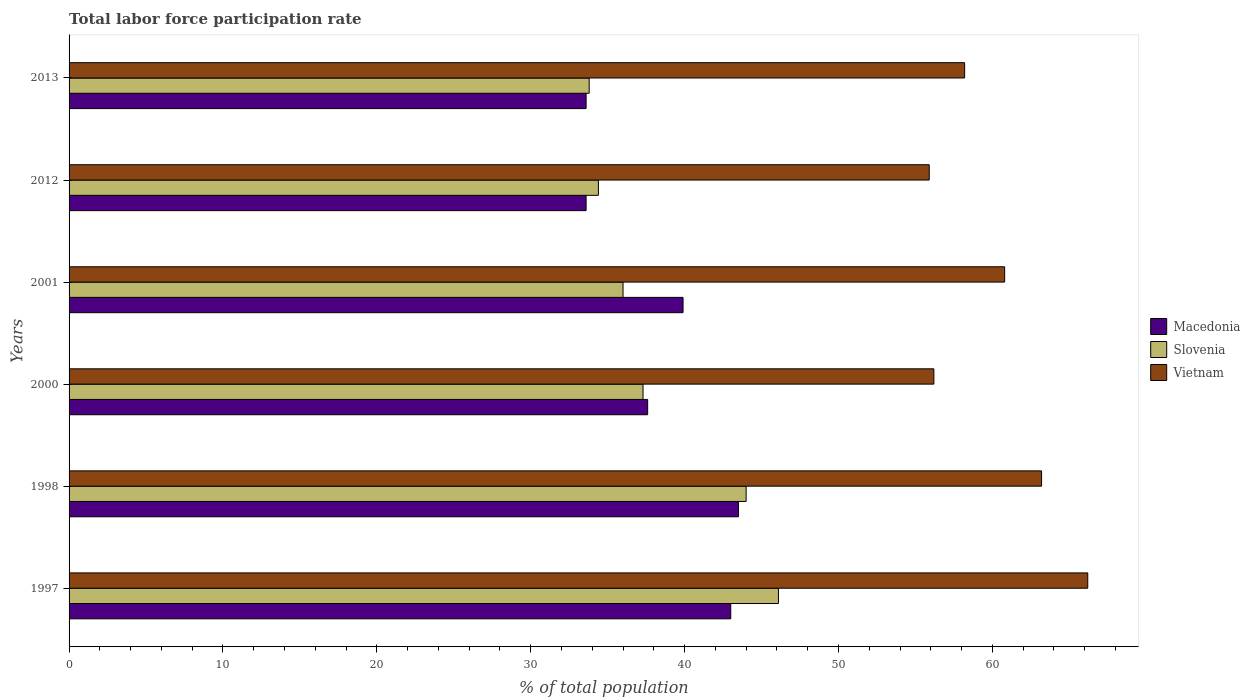Are the number of bars per tick equal to the number of legend labels?
Provide a succinct answer. Yes. How many bars are there on the 1st tick from the bottom?
Provide a succinct answer. 3. Across all years, what is the maximum total labor force participation rate in Macedonia?
Offer a very short reply. 43.5. Across all years, what is the minimum total labor force participation rate in Vietnam?
Ensure brevity in your answer.  55.9. In which year was the total labor force participation rate in Macedonia maximum?
Make the answer very short. 1998. In which year was the total labor force participation rate in Slovenia minimum?
Make the answer very short. 2013. What is the total total labor force participation rate in Slovenia in the graph?
Offer a terse response. 231.6. What is the difference between the total labor force participation rate in Slovenia in 1998 and the total labor force participation rate in Macedonia in 2012?
Your answer should be compact. 10.4. What is the average total labor force participation rate in Vietnam per year?
Give a very brief answer. 60.08. In the year 1998, what is the difference between the total labor force participation rate in Macedonia and total labor force participation rate in Slovenia?
Your answer should be compact. -0.5. In how many years, is the total labor force participation rate in Macedonia greater than 32 %?
Your response must be concise. 6. What is the ratio of the total labor force participation rate in Vietnam in 1998 to that in 2013?
Make the answer very short. 1.09. Is the total labor force participation rate in Macedonia in 2000 less than that in 2001?
Offer a terse response. Yes. Is the difference between the total labor force participation rate in Macedonia in 2000 and 2012 greater than the difference between the total labor force participation rate in Slovenia in 2000 and 2012?
Your answer should be very brief. Yes. What is the difference between the highest and the lowest total labor force participation rate in Macedonia?
Provide a short and direct response. 9.9. In how many years, is the total labor force participation rate in Slovenia greater than the average total labor force participation rate in Slovenia taken over all years?
Keep it short and to the point. 2. What does the 2nd bar from the top in 1997 represents?
Make the answer very short. Slovenia. What does the 3rd bar from the bottom in 1997 represents?
Provide a succinct answer. Vietnam. Is it the case that in every year, the sum of the total labor force participation rate in Vietnam and total labor force participation rate in Slovenia is greater than the total labor force participation rate in Macedonia?
Your answer should be very brief. Yes. How many bars are there?
Your answer should be very brief. 18. Are all the bars in the graph horizontal?
Provide a short and direct response. Yes. What is the difference between two consecutive major ticks on the X-axis?
Keep it short and to the point. 10. Are the values on the major ticks of X-axis written in scientific E-notation?
Make the answer very short. No. Does the graph contain any zero values?
Keep it short and to the point. No. Where does the legend appear in the graph?
Give a very brief answer. Center right. How many legend labels are there?
Ensure brevity in your answer.  3. How are the legend labels stacked?
Offer a terse response. Vertical. What is the title of the graph?
Make the answer very short. Total labor force participation rate. What is the label or title of the X-axis?
Provide a succinct answer. % of total population. What is the label or title of the Y-axis?
Your answer should be very brief. Years. What is the % of total population of Slovenia in 1997?
Your response must be concise. 46.1. What is the % of total population of Vietnam in 1997?
Provide a succinct answer. 66.2. What is the % of total population in Macedonia in 1998?
Provide a short and direct response. 43.5. What is the % of total population in Slovenia in 1998?
Ensure brevity in your answer.  44. What is the % of total population of Vietnam in 1998?
Provide a succinct answer. 63.2. What is the % of total population in Macedonia in 2000?
Make the answer very short. 37.6. What is the % of total population of Slovenia in 2000?
Give a very brief answer. 37.3. What is the % of total population in Vietnam in 2000?
Offer a very short reply. 56.2. What is the % of total population in Macedonia in 2001?
Your response must be concise. 39.9. What is the % of total population of Vietnam in 2001?
Keep it short and to the point. 60.8. What is the % of total population of Macedonia in 2012?
Offer a very short reply. 33.6. What is the % of total population of Slovenia in 2012?
Provide a short and direct response. 34.4. What is the % of total population in Vietnam in 2012?
Provide a short and direct response. 55.9. What is the % of total population in Macedonia in 2013?
Ensure brevity in your answer.  33.6. What is the % of total population in Slovenia in 2013?
Make the answer very short. 33.8. What is the % of total population of Vietnam in 2013?
Provide a succinct answer. 58.2. Across all years, what is the maximum % of total population of Macedonia?
Ensure brevity in your answer.  43.5. Across all years, what is the maximum % of total population in Slovenia?
Offer a terse response. 46.1. Across all years, what is the maximum % of total population of Vietnam?
Your response must be concise. 66.2. Across all years, what is the minimum % of total population of Macedonia?
Offer a terse response. 33.6. Across all years, what is the minimum % of total population in Slovenia?
Your answer should be compact. 33.8. Across all years, what is the minimum % of total population of Vietnam?
Keep it short and to the point. 55.9. What is the total % of total population in Macedonia in the graph?
Offer a very short reply. 231.2. What is the total % of total population in Slovenia in the graph?
Ensure brevity in your answer.  231.6. What is the total % of total population in Vietnam in the graph?
Offer a terse response. 360.5. What is the difference between the % of total population of Macedonia in 1997 and that in 1998?
Offer a terse response. -0.5. What is the difference between the % of total population of Slovenia in 1997 and that in 1998?
Ensure brevity in your answer.  2.1. What is the difference between the % of total population in Macedonia in 1997 and that in 2000?
Provide a short and direct response. 5.4. What is the difference between the % of total population of Macedonia in 1997 and that in 2001?
Make the answer very short. 3.1. What is the difference between the % of total population of Slovenia in 1997 and that in 2001?
Your answer should be very brief. 10.1. What is the difference between the % of total population in Macedonia in 1997 and that in 2012?
Offer a terse response. 9.4. What is the difference between the % of total population of Vietnam in 1997 and that in 2012?
Make the answer very short. 10.3. What is the difference between the % of total population of Slovenia in 1997 and that in 2013?
Make the answer very short. 12.3. What is the difference between the % of total population of Macedonia in 1998 and that in 2000?
Make the answer very short. 5.9. What is the difference between the % of total population in Macedonia in 1998 and that in 2001?
Offer a very short reply. 3.6. What is the difference between the % of total population in Slovenia in 1998 and that in 2001?
Give a very brief answer. 8. What is the difference between the % of total population in Vietnam in 1998 and that in 2001?
Offer a terse response. 2.4. What is the difference between the % of total population in Macedonia in 1998 and that in 2012?
Keep it short and to the point. 9.9. What is the difference between the % of total population in Slovenia in 1998 and that in 2012?
Keep it short and to the point. 9.6. What is the difference between the % of total population of Vietnam in 1998 and that in 2012?
Give a very brief answer. 7.3. What is the difference between the % of total population of Slovenia in 2000 and that in 2001?
Ensure brevity in your answer.  1.3. What is the difference between the % of total population in Slovenia in 2000 and that in 2013?
Your answer should be very brief. 3.5. What is the difference between the % of total population in Vietnam in 2000 and that in 2013?
Ensure brevity in your answer.  -2. What is the difference between the % of total population in Macedonia in 2001 and that in 2013?
Keep it short and to the point. 6.3. What is the difference between the % of total population in Slovenia in 2012 and that in 2013?
Provide a short and direct response. 0.6. What is the difference between the % of total population of Vietnam in 2012 and that in 2013?
Make the answer very short. -2.3. What is the difference between the % of total population in Macedonia in 1997 and the % of total population in Slovenia in 1998?
Your answer should be compact. -1. What is the difference between the % of total population of Macedonia in 1997 and the % of total population of Vietnam in 1998?
Provide a short and direct response. -20.2. What is the difference between the % of total population in Slovenia in 1997 and the % of total population in Vietnam in 1998?
Make the answer very short. -17.1. What is the difference between the % of total population of Macedonia in 1997 and the % of total population of Slovenia in 2000?
Make the answer very short. 5.7. What is the difference between the % of total population of Macedonia in 1997 and the % of total population of Vietnam in 2001?
Keep it short and to the point. -17.8. What is the difference between the % of total population of Slovenia in 1997 and the % of total population of Vietnam in 2001?
Your response must be concise. -14.7. What is the difference between the % of total population of Macedonia in 1997 and the % of total population of Slovenia in 2013?
Provide a short and direct response. 9.2. What is the difference between the % of total population of Macedonia in 1997 and the % of total population of Vietnam in 2013?
Your response must be concise. -15.2. What is the difference between the % of total population of Slovenia in 1998 and the % of total population of Vietnam in 2000?
Ensure brevity in your answer.  -12.2. What is the difference between the % of total population in Macedonia in 1998 and the % of total population in Slovenia in 2001?
Make the answer very short. 7.5. What is the difference between the % of total population in Macedonia in 1998 and the % of total population in Vietnam in 2001?
Keep it short and to the point. -17.3. What is the difference between the % of total population of Slovenia in 1998 and the % of total population of Vietnam in 2001?
Give a very brief answer. -16.8. What is the difference between the % of total population in Macedonia in 1998 and the % of total population in Vietnam in 2012?
Your response must be concise. -12.4. What is the difference between the % of total population in Slovenia in 1998 and the % of total population in Vietnam in 2012?
Your response must be concise. -11.9. What is the difference between the % of total population in Macedonia in 1998 and the % of total population in Vietnam in 2013?
Provide a succinct answer. -14.7. What is the difference between the % of total population in Macedonia in 2000 and the % of total population in Slovenia in 2001?
Offer a very short reply. 1.6. What is the difference between the % of total population in Macedonia in 2000 and the % of total population in Vietnam in 2001?
Offer a very short reply. -23.2. What is the difference between the % of total population of Slovenia in 2000 and the % of total population of Vietnam in 2001?
Your response must be concise. -23.5. What is the difference between the % of total population in Macedonia in 2000 and the % of total population in Slovenia in 2012?
Keep it short and to the point. 3.2. What is the difference between the % of total population in Macedonia in 2000 and the % of total population in Vietnam in 2012?
Give a very brief answer. -18.3. What is the difference between the % of total population in Slovenia in 2000 and the % of total population in Vietnam in 2012?
Offer a very short reply. -18.6. What is the difference between the % of total population in Macedonia in 2000 and the % of total population in Vietnam in 2013?
Provide a short and direct response. -20.6. What is the difference between the % of total population in Slovenia in 2000 and the % of total population in Vietnam in 2013?
Provide a short and direct response. -20.9. What is the difference between the % of total population in Macedonia in 2001 and the % of total population in Slovenia in 2012?
Give a very brief answer. 5.5. What is the difference between the % of total population in Slovenia in 2001 and the % of total population in Vietnam in 2012?
Provide a short and direct response. -19.9. What is the difference between the % of total population of Macedonia in 2001 and the % of total population of Slovenia in 2013?
Your answer should be compact. 6.1. What is the difference between the % of total population of Macedonia in 2001 and the % of total population of Vietnam in 2013?
Your answer should be very brief. -18.3. What is the difference between the % of total population in Slovenia in 2001 and the % of total population in Vietnam in 2013?
Your answer should be compact. -22.2. What is the difference between the % of total population of Macedonia in 2012 and the % of total population of Slovenia in 2013?
Give a very brief answer. -0.2. What is the difference between the % of total population of Macedonia in 2012 and the % of total population of Vietnam in 2013?
Your answer should be compact. -24.6. What is the difference between the % of total population in Slovenia in 2012 and the % of total population in Vietnam in 2013?
Offer a terse response. -23.8. What is the average % of total population in Macedonia per year?
Your answer should be compact. 38.53. What is the average % of total population of Slovenia per year?
Make the answer very short. 38.6. What is the average % of total population in Vietnam per year?
Keep it short and to the point. 60.08. In the year 1997, what is the difference between the % of total population in Macedonia and % of total population in Slovenia?
Keep it short and to the point. -3.1. In the year 1997, what is the difference between the % of total population of Macedonia and % of total population of Vietnam?
Provide a succinct answer. -23.2. In the year 1997, what is the difference between the % of total population of Slovenia and % of total population of Vietnam?
Your response must be concise. -20.1. In the year 1998, what is the difference between the % of total population of Macedonia and % of total population of Slovenia?
Provide a succinct answer. -0.5. In the year 1998, what is the difference between the % of total population of Macedonia and % of total population of Vietnam?
Your answer should be compact. -19.7. In the year 1998, what is the difference between the % of total population of Slovenia and % of total population of Vietnam?
Offer a terse response. -19.2. In the year 2000, what is the difference between the % of total population of Macedonia and % of total population of Vietnam?
Keep it short and to the point. -18.6. In the year 2000, what is the difference between the % of total population of Slovenia and % of total population of Vietnam?
Offer a terse response. -18.9. In the year 2001, what is the difference between the % of total population in Macedonia and % of total population in Vietnam?
Your answer should be compact. -20.9. In the year 2001, what is the difference between the % of total population of Slovenia and % of total population of Vietnam?
Your answer should be very brief. -24.8. In the year 2012, what is the difference between the % of total population of Macedonia and % of total population of Vietnam?
Ensure brevity in your answer.  -22.3. In the year 2012, what is the difference between the % of total population in Slovenia and % of total population in Vietnam?
Your response must be concise. -21.5. In the year 2013, what is the difference between the % of total population of Macedonia and % of total population of Slovenia?
Offer a very short reply. -0.2. In the year 2013, what is the difference between the % of total population in Macedonia and % of total population in Vietnam?
Provide a short and direct response. -24.6. In the year 2013, what is the difference between the % of total population of Slovenia and % of total population of Vietnam?
Keep it short and to the point. -24.4. What is the ratio of the % of total population of Macedonia in 1997 to that in 1998?
Your answer should be compact. 0.99. What is the ratio of the % of total population of Slovenia in 1997 to that in 1998?
Provide a succinct answer. 1.05. What is the ratio of the % of total population of Vietnam in 1997 to that in 1998?
Provide a succinct answer. 1.05. What is the ratio of the % of total population of Macedonia in 1997 to that in 2000?
Provide a short and direct response. 1.14. What is the ratio of the % of total population in Slovenia in 1997 to that in 2000?
Make the answer very short. 1.24. What is the ratio of the % of total population of Vietnam in 1997 to that in 2000?
Offer a terse response. 1.18. What is the ratio of the % of total population of Macedonia in 1997 to that in 2001?
Provide a succinct answer. 1.08. What is the ratio of the % of total population of Slovenia in 1997 to that in 2001?
Your answer should be compact. 1.28. What is the ratio of the % of total population in Vietnam in 1997 to that in 2001?
Provide a succinct answer. 1.09. What is the ratio of the % of total population of Macedonia in 1997 to that in 2012?
Make the answer very short. 1.28. What is the ratio of the % of total population of Slovenia in 1997 to that in 2012?
Your response must be concise. 1.34. What is the ratio of the % of total population in Vietnam in 1997 to that in 2012?
Provide a succinct answer. 1.18. What is the ratio of the % of total population of Macedonia in 1997 to that in 2013?
Make the answer very short. 1.28. What is the ratio of the % of total population in Slovenia in 1997 to that in 2013?
Provide a succinct answer. 1.36. What is the ratio of the % of total population in Vietnam in 1997 to that in 2013?
Your answer should be very brief. 1.14. What is the ratio of the % of total population in Macedonia in 1998 to that in 2000?
Provide a short and direct response. 1.16. What is the ratio of the % of total population of Slovenia in 1998 to that in 2000?
Your response must be concise. 1.18. What is the ratio of the % of total population in Vietnam in 1998 to that in 2000?
Offer a very short reply. 1.12. What is the ratio of the % of total population of Macedonia in 1998 to that in 2001?
Offer a very short reply. 1.09. What is the ratio of the % of total population of Slovenia in 1998 to that in 2001?
Your answer should be compact. 1.22. What is the ratio of the % of total population in Vietnam in 1998 to that in 2001?
Provide a short and direct response. 1.04. What is the ratio of the % of total population in Macedonia in 1998 to that in 2012?
Provide a short and direct response. 1.29. What is the ratio of the % of total population in Slovenia in 1998 to that in 2012?
Your answer should be very brief. 1.28. What is the ratio of the % of total population in Vietnam in 1998 to that in 2012?
Your response must be concise. 1.13. What is the ratio of the % of total population in Macedonia in 1998 to that in 2013?
Give a very brief answer. 1.29. What is the ratio of the % of total population of Slovenia in 1998 to that in 2013?
Your answer should be compact. 1.3. What is the ratio of the % of total population of Vietnam in 1998 to that in 2013?
Your answer should be compact. 1.09. What is the ratio of the % of total population of Macedonia in 2000 to that in 2001?
Your answer should be very brief. 0.94. What is the ratio of the % of total population of Slovenia in 2000 to that in 2001?
Provide a succinct answer. 1.04. What is the ratio of the % of total population of Vietnam in 2000 to that in 2001?
Provide a succinct answer. 0.92. What is the ratio of the % of total population in Macedonia in 2000 to that in 2012?
Offer a terse response. 1.12. What is the ratio of the % of total population of Slovenia in 2000 to that in 2012?
Provide a short and direct response. 1.08. What is the ratio of the % of total population in Vietnam in 2000 to that in 2012?
Your answer should be very brief. 1.01. What is the ratio of the % of total population of Macedonia in 2000 to that in 2013?
Your answer should be compact. 1.12. What is the ratio of the % of total population in Slovenia in 2000 to that in 2013?
Give a very brief answer. 1.1. What is the ratio of the % of total population in Vietnam in 2000 to that in 2013?
Ensure brevity in your answer.  0.97. What is the ratio of the % of total population of Macedonia in 2001 to that in 2012?
Offer a very short reply. 1.19. What is the ratio of the % of total population of Slovenia in 2001 to that in 2012?
Make the answer very short. 1.05. What is the ratio of the % of total population of Vietnam in 2001 to that in 2012?
Your response must be concise. 1.09. What is the ratio of the % of total population of Macedonia in 2001 to that in 2013?
Offer a very short reply. 1.19. What is the ratio of the % of total population of Slovenia in 2001 to that in 2013?
Offer a very short reply. 1.07. What is the ratio of the % of total population in Vietnam in 2001 to that in 2013?
Your answer should be very brief. 1.04. What is the ratio of the % of total population in Macedonia in 2012 to that in 2013?
Ensure brevity in your answer.  1. What is the ratio of the % of total population of Slovenia in 2012 to that in 2013?
Your answer should be very brief. 1.02. What is the ratio of the % of total population in Vietnam in 2012 to that in 2013?
Your response must be concise. 0.96. What is the difference between the highest and the second highest % of total population of Macedonia?
Your response must be concise. 0.5. What is the difference between the highest and the lowest % of total population of Slovenia?
Provide a short and direct response. 12.3. What is the difference between the highest and the lowest % of total population in Vietnam?
Ensure brevity in your answer.  10.3. 